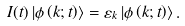Convert formula to latex. <formula><loc_0><loc_0><loc_500><loc_500>I ( t ) \left | \phi \left ( k ; t \right ) \right \rangle = \varepsilon _ { k } \left | \phi \left ( k ; t \right ) \right \rangle .</formula> 